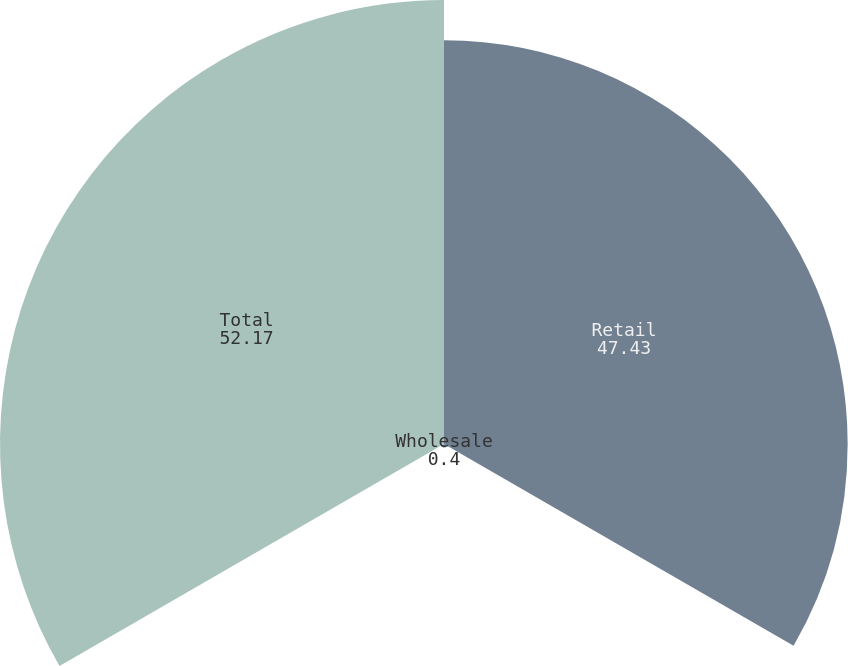<chart> <loc_0><loc_0><loc_500><loc_500><pie_chart><fcel>Retail<fcel>Wholesale<fcel>Total<nl><fcel>47.43%<fcel>0.4%<fcel>52.17%<nl></chart> 